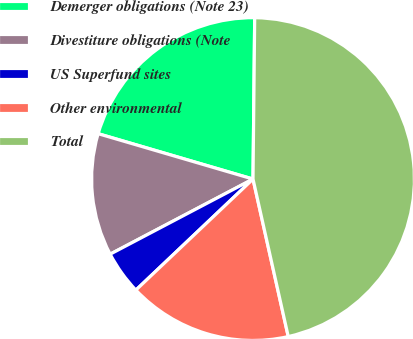<chart> <loc_0><loc_0><loc_500><loc_500><pie_chart><fcel>Demerger obligations (Note 23)<fcel>Divestiture obligations (Note<fcel>US Superfund sites<fcel>Other environmental<fcel>Total<nl><fcel>20.63%<fcel>12.24%<fcel>4.37%<fcel>16.43%<fcel>46.33%<nl></chart> 